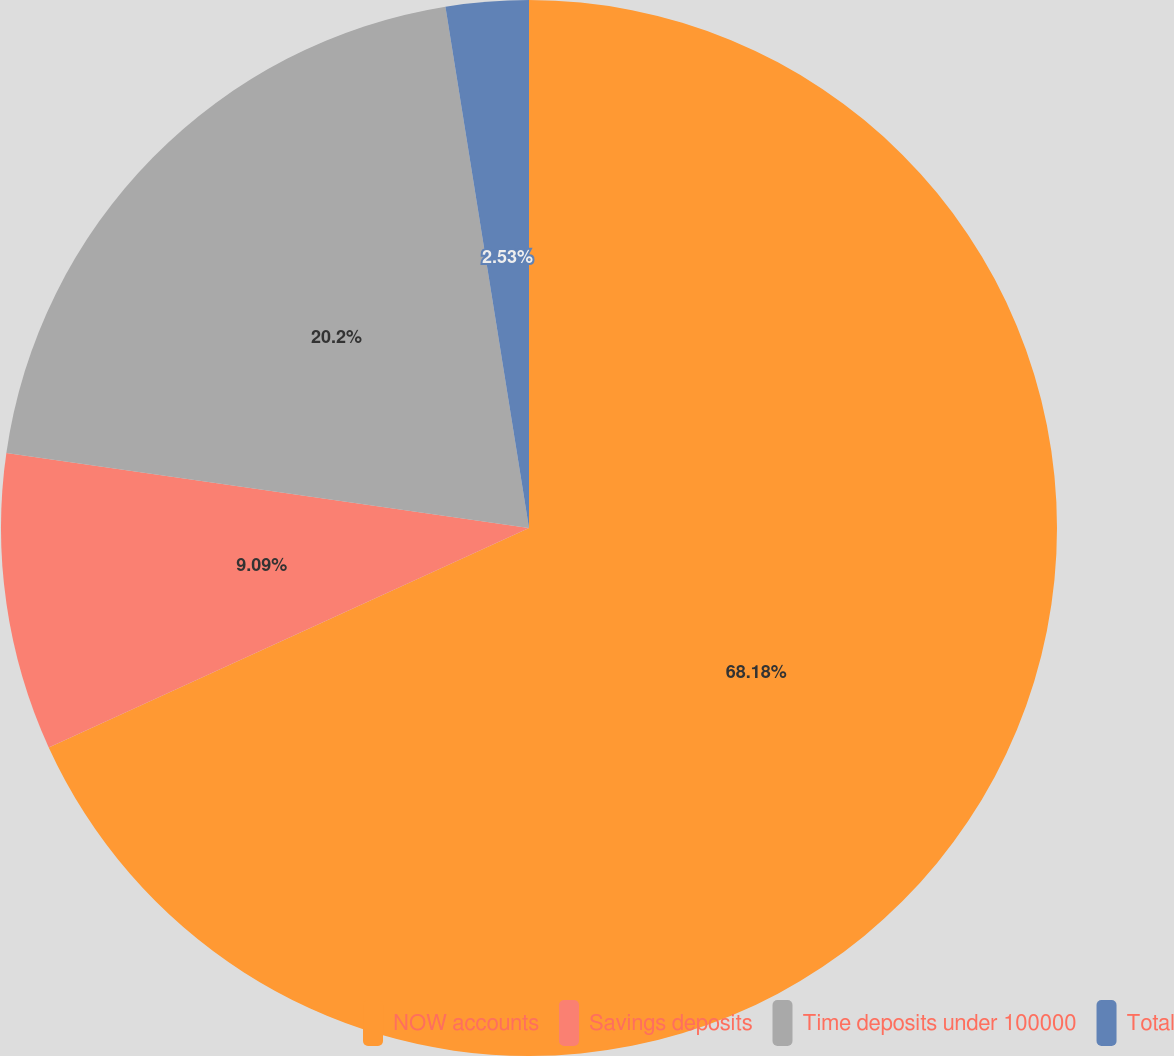Convert chart to OTSL. <chart><loc_0><loc_0><loc_500><loc_500><pie_chart><fcel>NOW accounts<fcel>Savings deposits<fcel>Time deposits under 100000<fcel>Total<nl><fcel>68.18%<fcel>9.09%<fcel>20.2%<fcel>2.53%<nl></chart> 